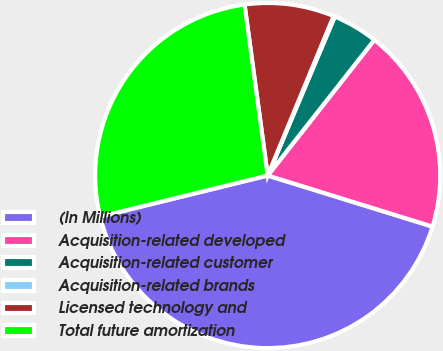<chart> <loc_0><loc_0><loc_500><loc_500><pie_chart><fcel>(In Millions)<fcel>Acquisition-related developed<fcel>Acquisition-related customer<fcel>Acquisition-related brands<fcel>Licensed technology and<fcel>Total future amortization<nl><fcel>41.39%<fcel>19.18%<fcel>4.25%<fcel>0.12%<fcel>8.38%<fcel>26.69%<nl></chart> 